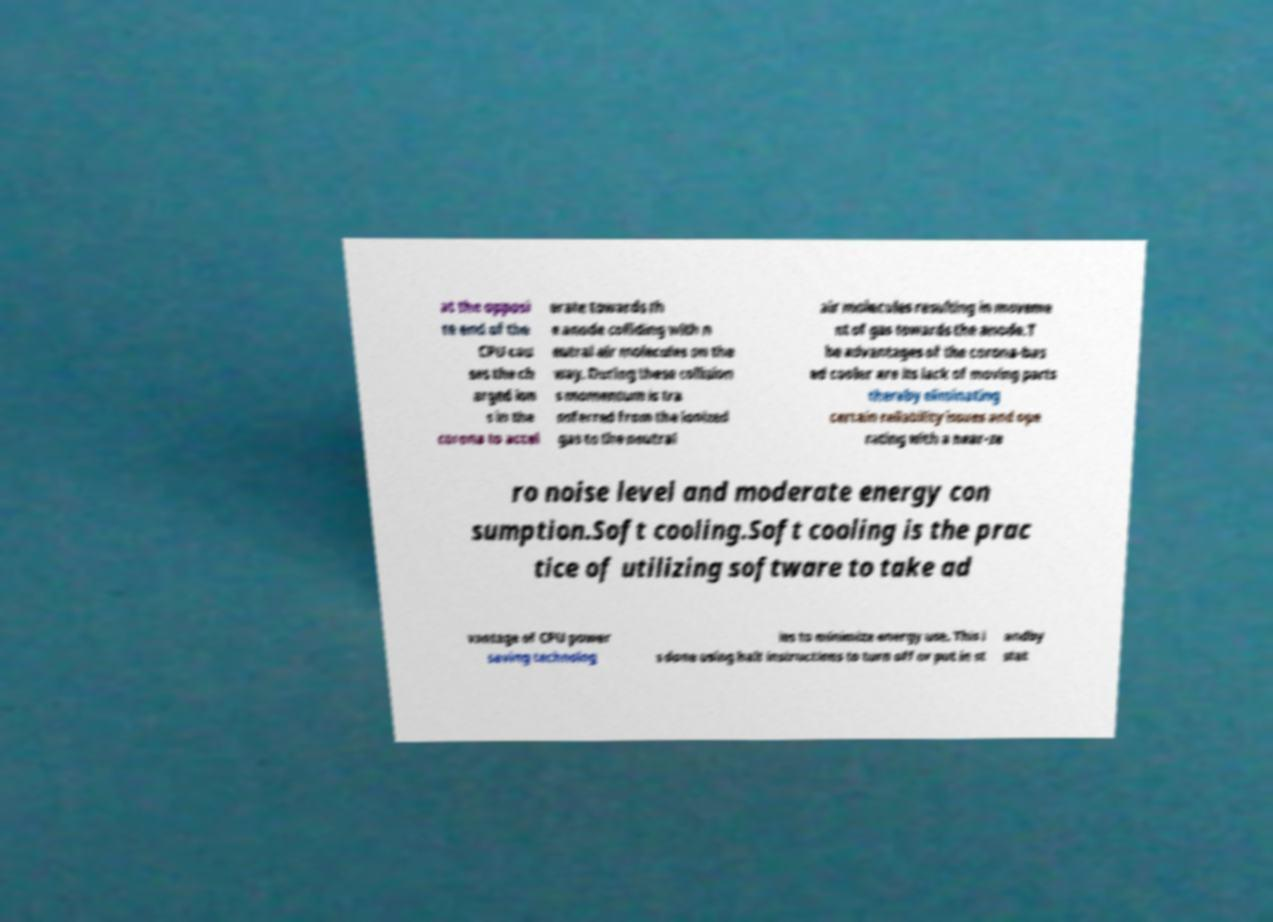What messages or text are displayed in this image? I need them in a readable, typed format. at the opposi te end of the CPU cau ses the ch arged ion s in the corona to accel erate towards th e anode colliding with n eutral air molecules on the way. During these collision s momentum is tra nsferred from the ionized gas to the neutral air molecules resulting in moveme nt of gas towards the anode.T he advantages of the corona-bas ed cooler are its lack of moving parts thereby eliminating certain reliability issues and ope rating with a near-ze ro noise level and moderate energy con sumption.Soft cooling.Soft cooling is the prac tice of utilizing software to take ad vantage of CPU power saving technolog ies to minimize energy use. This i s done using halt instructions to turn off or put in st andby stat 